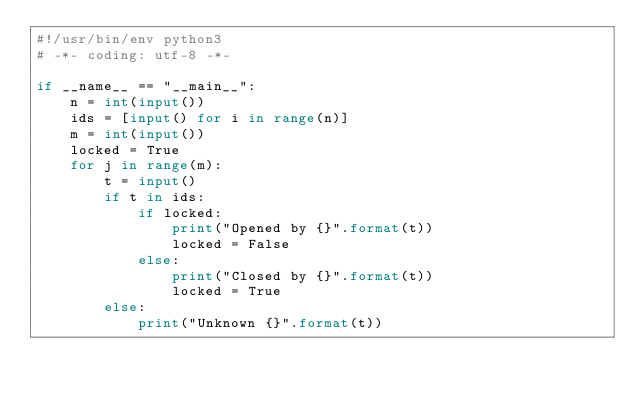<code> <loc_0><loc_0><loc_500><loc_500><_Python_>#!/usr/bin/env python3
# -*- coding: utf-8 -*-

if __name__ == "__main__":
    n = int(input())
    ids = [input() for i in range(n)]
    m = int(input())
    locked = True
    for j in range(m):
        t = input()
        if t in ids:
            if locked:
                print("Opened by {}".format(t))
                locked = False
            else:
                print("Closed by {}".format(t))
                locked = True
        else:
            print("Unknown {}".format(t))</code> 